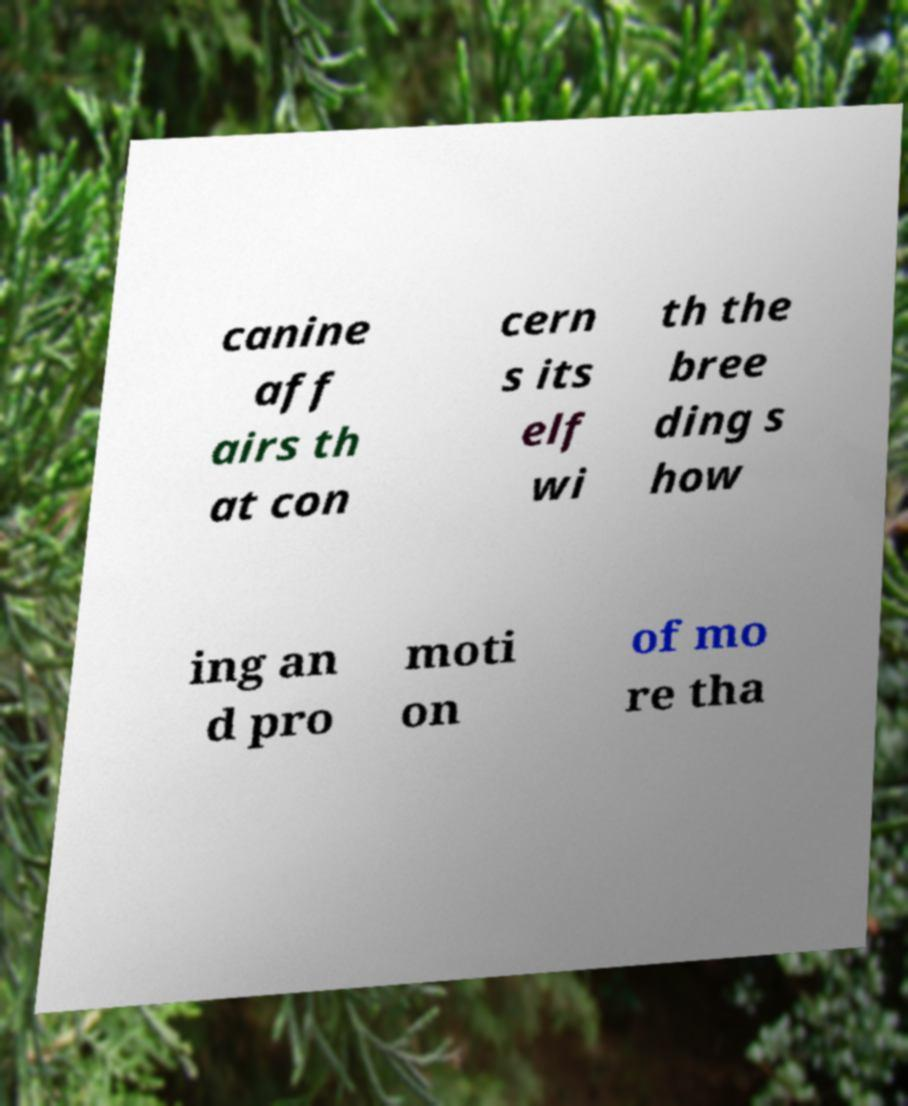Could you extract and type out the text from this image? canine aff airs th at con cern s its elf wi th the bree ding s how ing an d pro moti on of mo re tha 